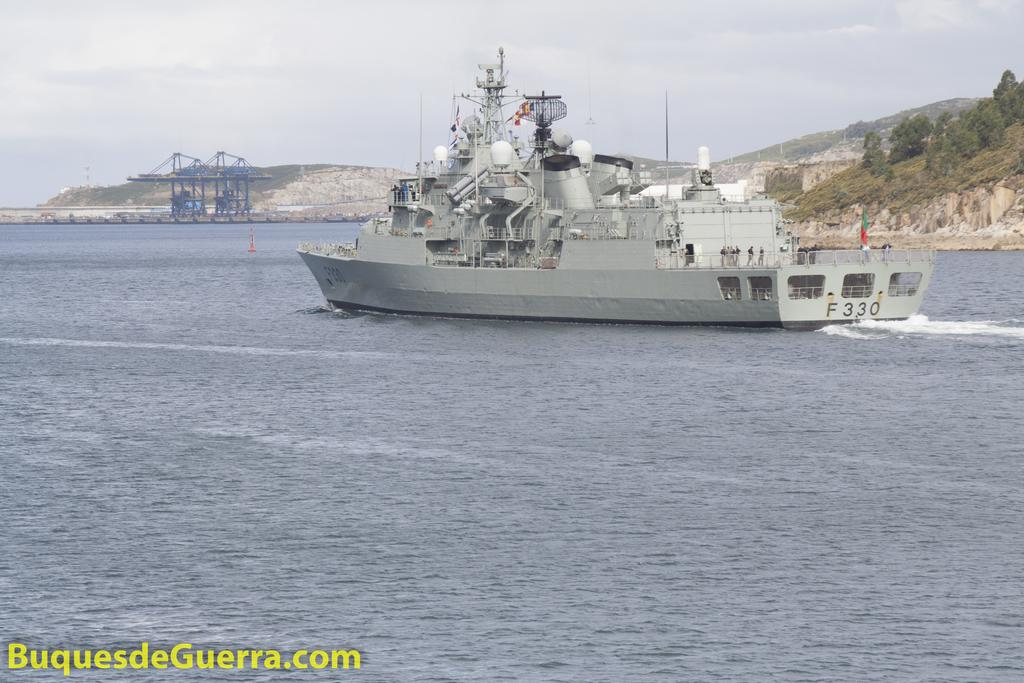<image>
Present a compact description of the photo's key features. A boat that has F330 on the back side. 